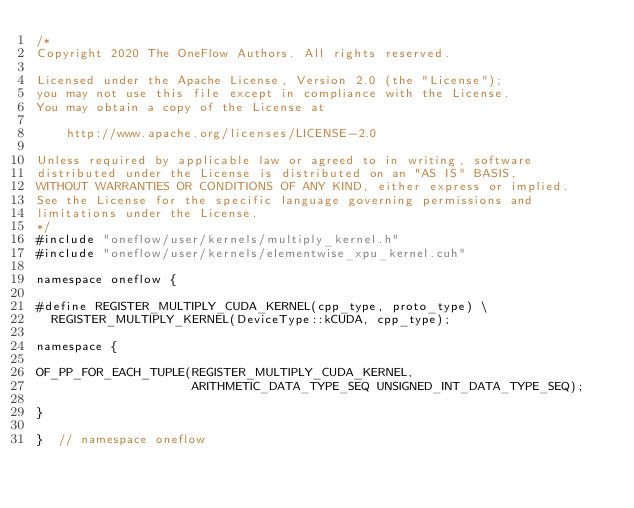Convert code to text. <code><loc_0><loc_0><loc_500><loc_500><_Cuda_>/*
Copyright 2020 The OneFlow Authors. All rights reserved.

Licensed under the Apache License, Version 2.0 (the "License");
you may not use this file except in compliance with the License.
You may obtain a copy of the License at

    http://www.apache.org/licenses/LICENSE-2.0

Unless required by applicable law or agreed to in writing, software
distributed under the License is distributed on an "AS IS" BASIS,
WITHOUT WARRANTIES OR CONDITIONS OF ANY KIND, either express or implied.
See the License for the specific language governing permissions and
limitations under the License.
*/
#include "oneflow/user/kernels/multiply_kernel.h"
#include "oneflow/user/kernels/elementwise_xpu_kernel.cuh"

namespace oneflow {

#define REGISTER_MULTIPLY_CUDA_KERNEL(cpp_type, proto_type) \
  REGISTER_MULTIPLY_KERNEL(DeviceType::kCUDA, cpp_type);

namespace {

OF_PP_FOR_EACH_TUPLE(REGISTER_MULTIPLY_CUDA_KERNEL,
                     ARITHMETIC_DATA_TYPE_SEQ UNSIGNED_INT_DATA_TYPE_SEQ);

}

}  // namespace oneflow
</code> 